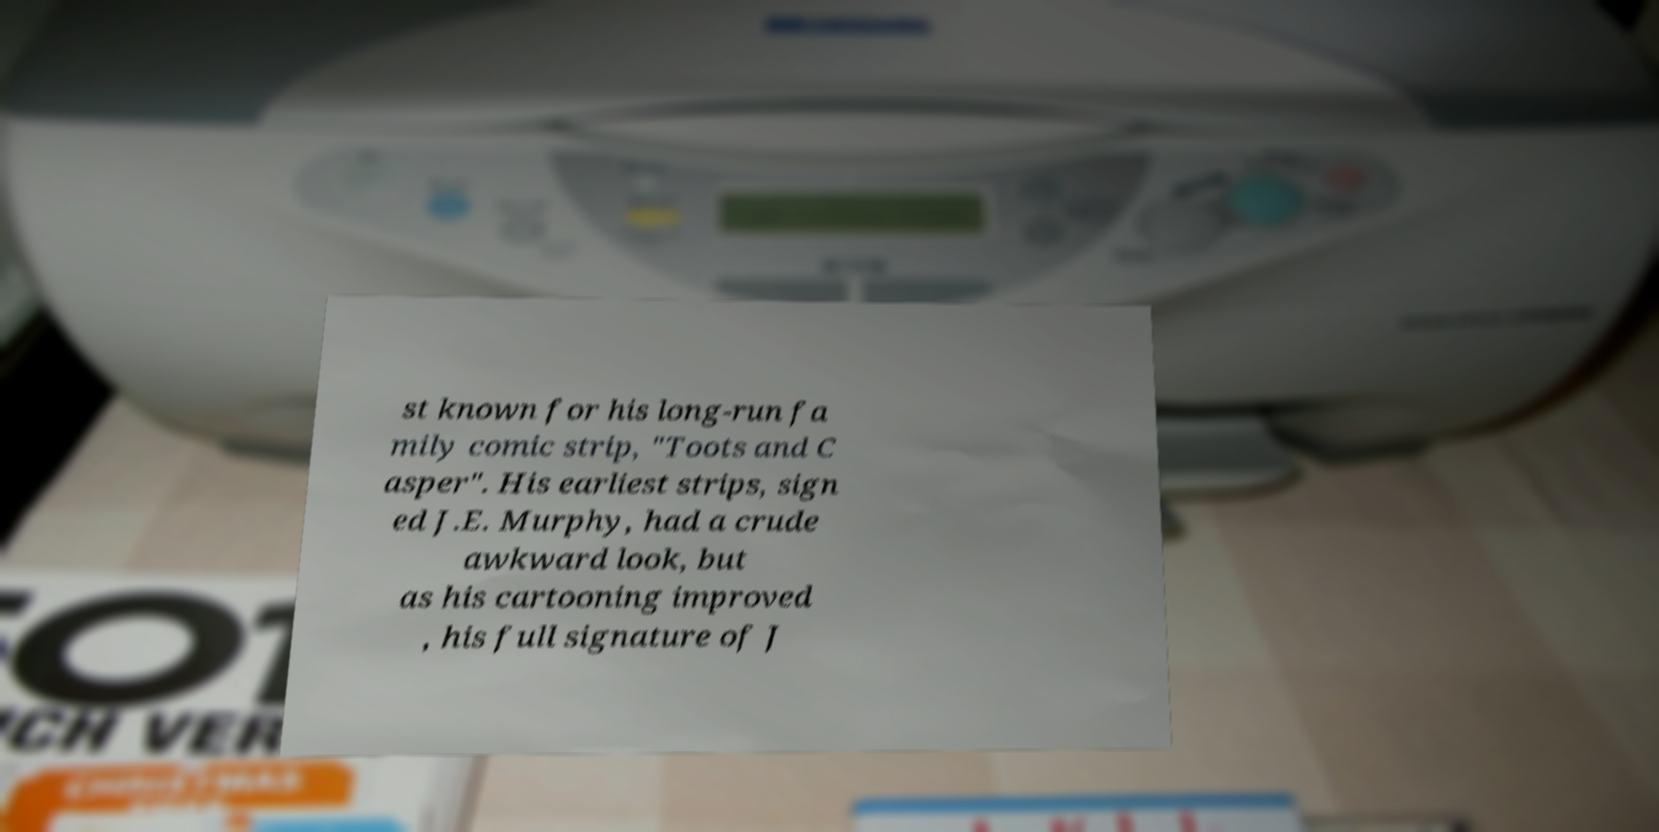Please identify and transcribe the text found in this image. st known for his long-run fa mily comic strip, "Toots and C asper". His earliest strips, sign ed J.E. Murphy, had a crude awkward look, but as his cartooning improved , his full signature of J 